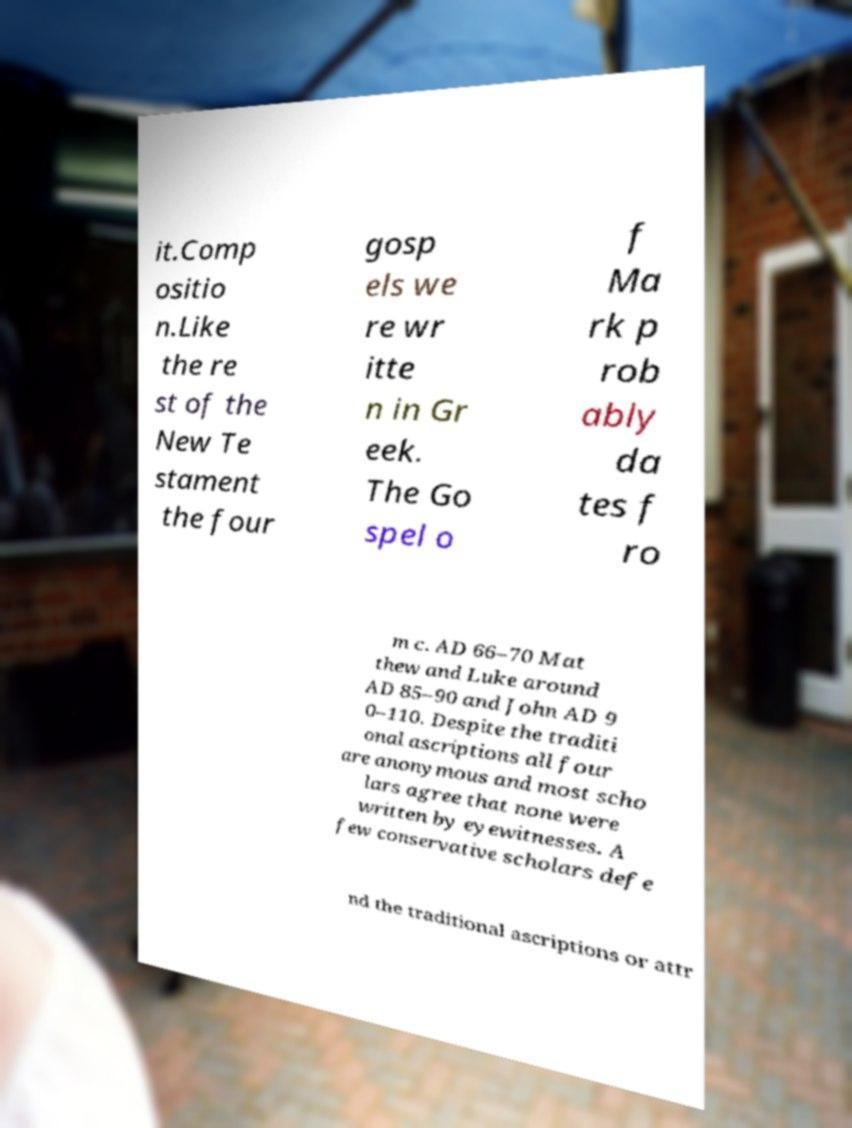For documentation purposes, I need the text within this image transcribed. Could you provide that? it.Comp ositio n.Like the re st of the New Te stament the four gosp els we re wr itte n in Gr eek. The Go spel o f Ma rk p rob ably da tes f ro m c. AD 66–70 Mat thew and Luke around AD 85–90 and John AD 9 0–110. Despite the traditi onal ascriptions all four are anonymous and most scho lars agree that none were written by eyewitnesses. A few conservative scholars defe nd the traditional ascriptions or attr 